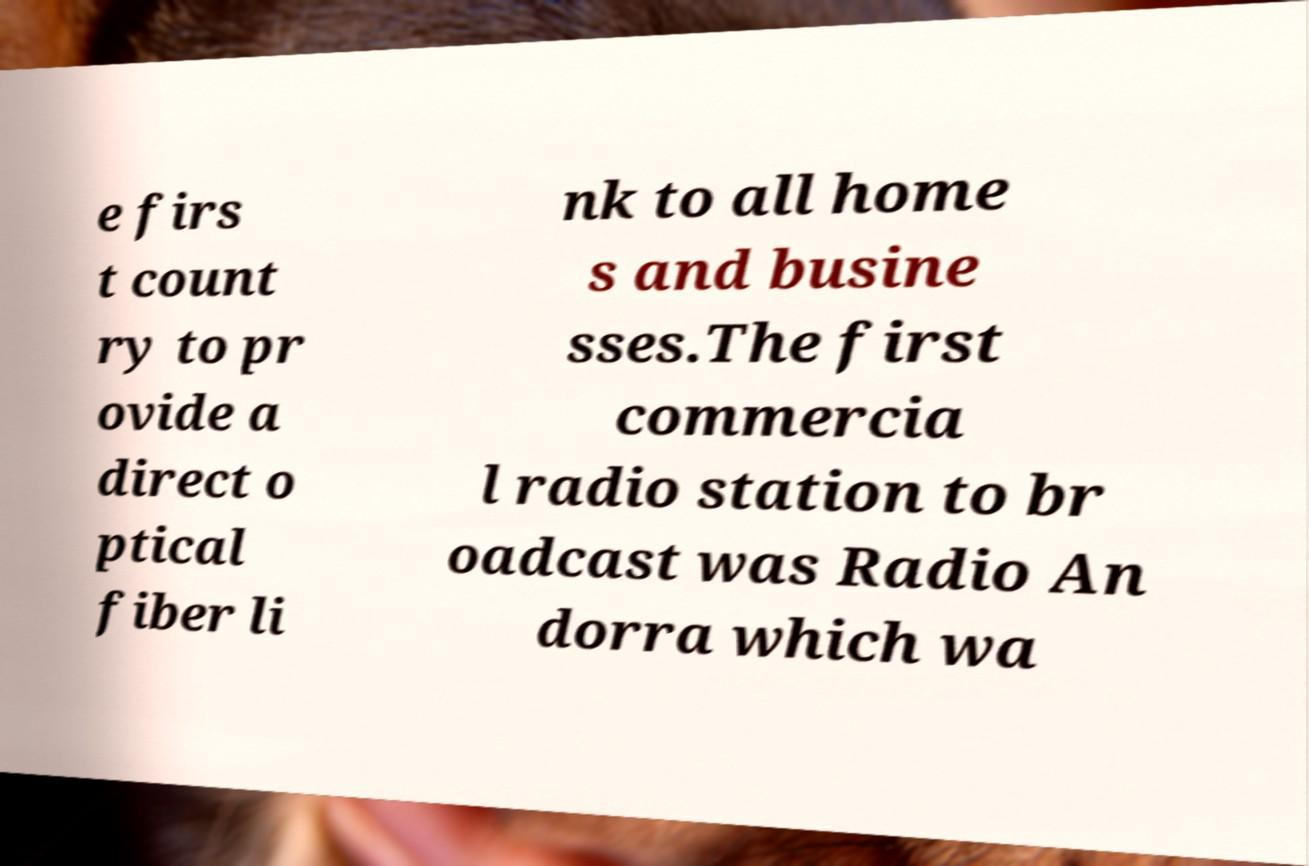I need the written content from this picture converted into text. Can you do that? e firs t count ry to pr ovide a direct o ptical fiber li nk to all home s and busine sses.The first commercia l radio station to br oadcast was Radio An dorra which wa 